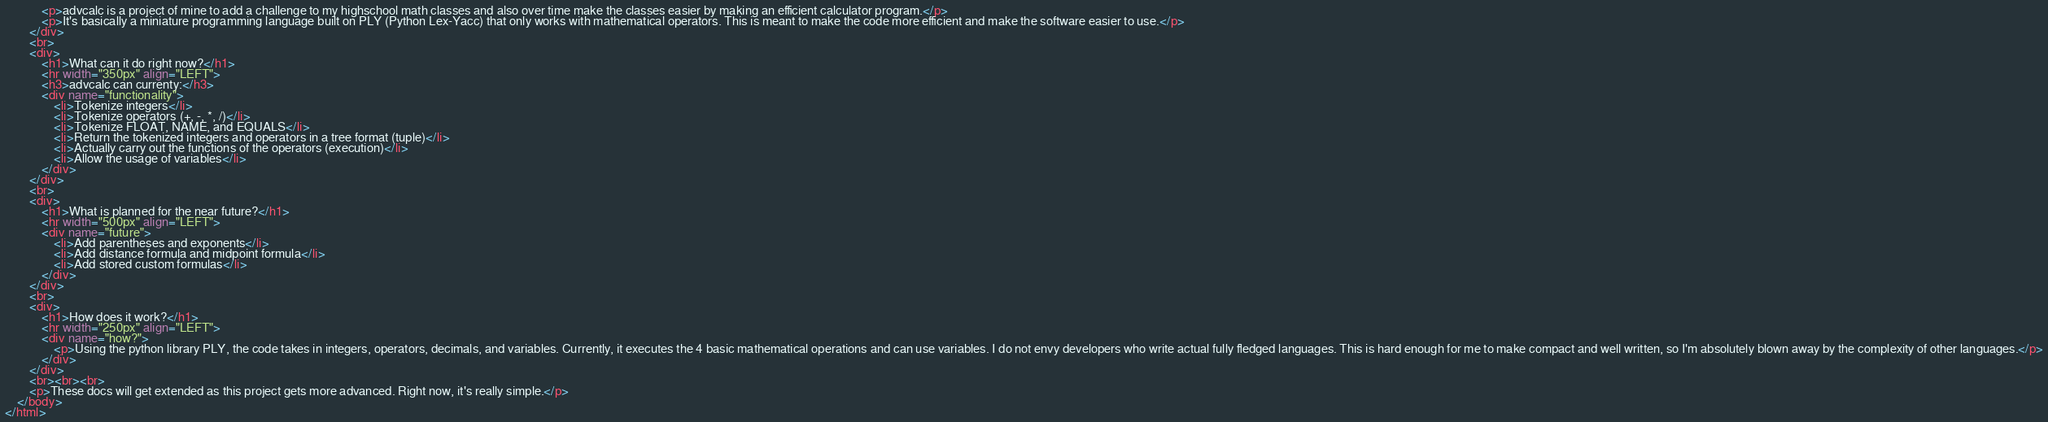<code> <loc_0><loc_0><loc_500><loc_500><_HTML_>			<p>advcalc is a project of mine to add a challenge to my highschool math classes and also over time make the classes easier by making an efficient calculator program.</p>
			<p>It's basically a miniature programming language built on PLY (Python Lex-Yacc) that only works with mathematical operators. This is meant to make the code more efficient and make the software easier to use.</p>
		</div>
		<br>
		<div>
			<h1>What can it do right now?</h1>
			<hr width="350px" align="LEFT">
			<h3>advcalc can currenty:</h3>
			<div name="functionality">
				<li>Tokenize integers</li>
				<li>Tokenize operators (+, -, *, /)</li>
				<li>Tokenize FLOAT, NAME, and EQUALS</li>
				<li>Return the tokenized integers and operators in a tree format (tuple)</li>
				<li>Actually carry out the functions of the operators (execution)</li>
				<li>Allow the usage of variables</li>
			</div>
		</div>
		<br>
		<div>
			<h1>What is planned for the near future?</h1>
			<hr width="500px" align="LEFT">
			<div name="future">
				<li>Add parentheses and exponents</li>
				<li>Add distance formula and midpoint formula</li>
				<li>Add stored custom formulas</li>
			</div>
		</div>
		<br>
		<div>
			<h1>How does it work?</h1>
			<hr width="250px" align="LEFT">
			<div name="how?">
				<p>Using the python library PLY, the code takes in integers, operators, decimals, and variables. Currently, it executes the 4 basic mathematical operations and can use variables. I do not envy developers who write actual fully fledged languages. This is hard enough for me to make compact and well written, so I'm absolutely blown away by the complexity of other languages.</p>
			</div>
		</div>
		<br><br><br>
		<p>These docs will get extended as this project gets more advanced. Right now, it's really simple.</p>
	</body>
</html>

</code> 